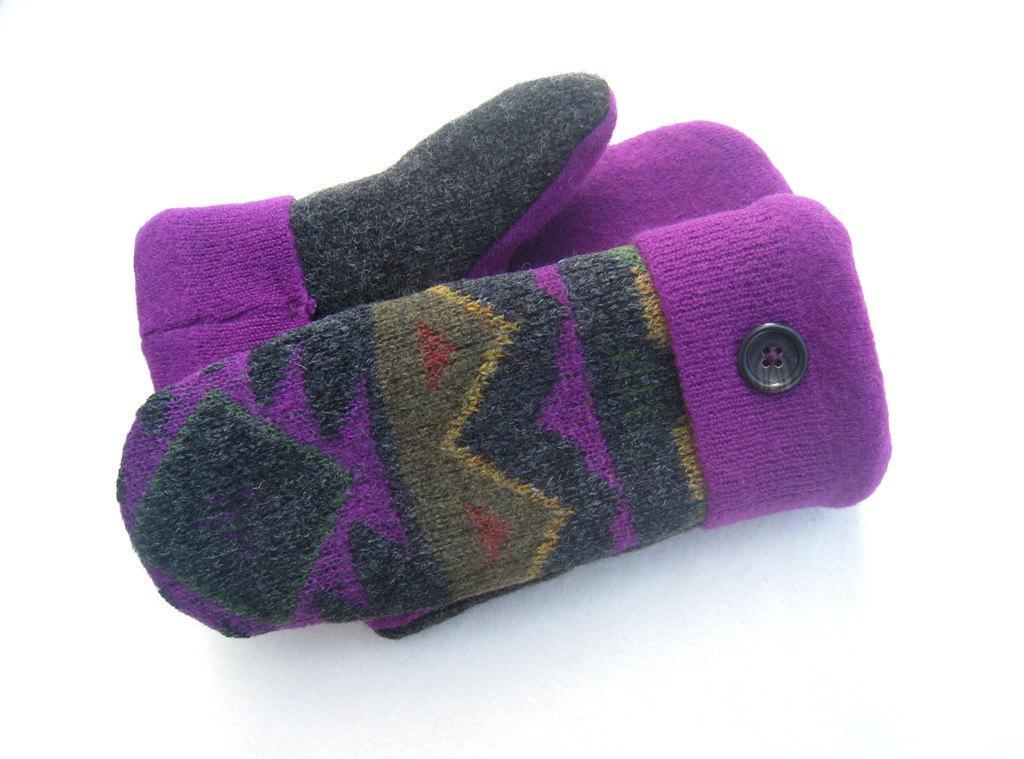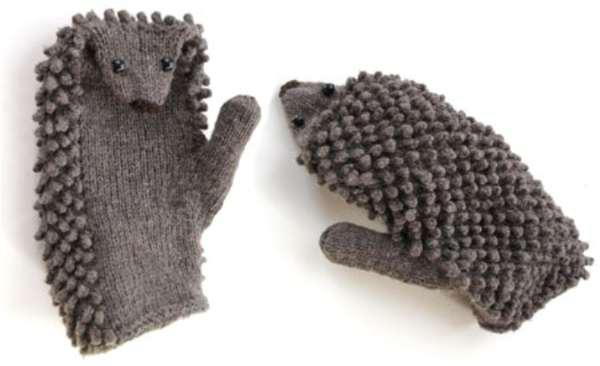The first image is the image on the left, the second image is the image on the right. For the images displayed, is the sentence "One of the pairs of mittens is gray knit with a vertical braid-like pattern running its length." factually correct? Answer yes or no. No. The first image is the image on the left, the second image is the image on the right. Considering the images on both sides, is "The mittens in the image on the left are made of a solid color." valid? Answer yes or no. No. 